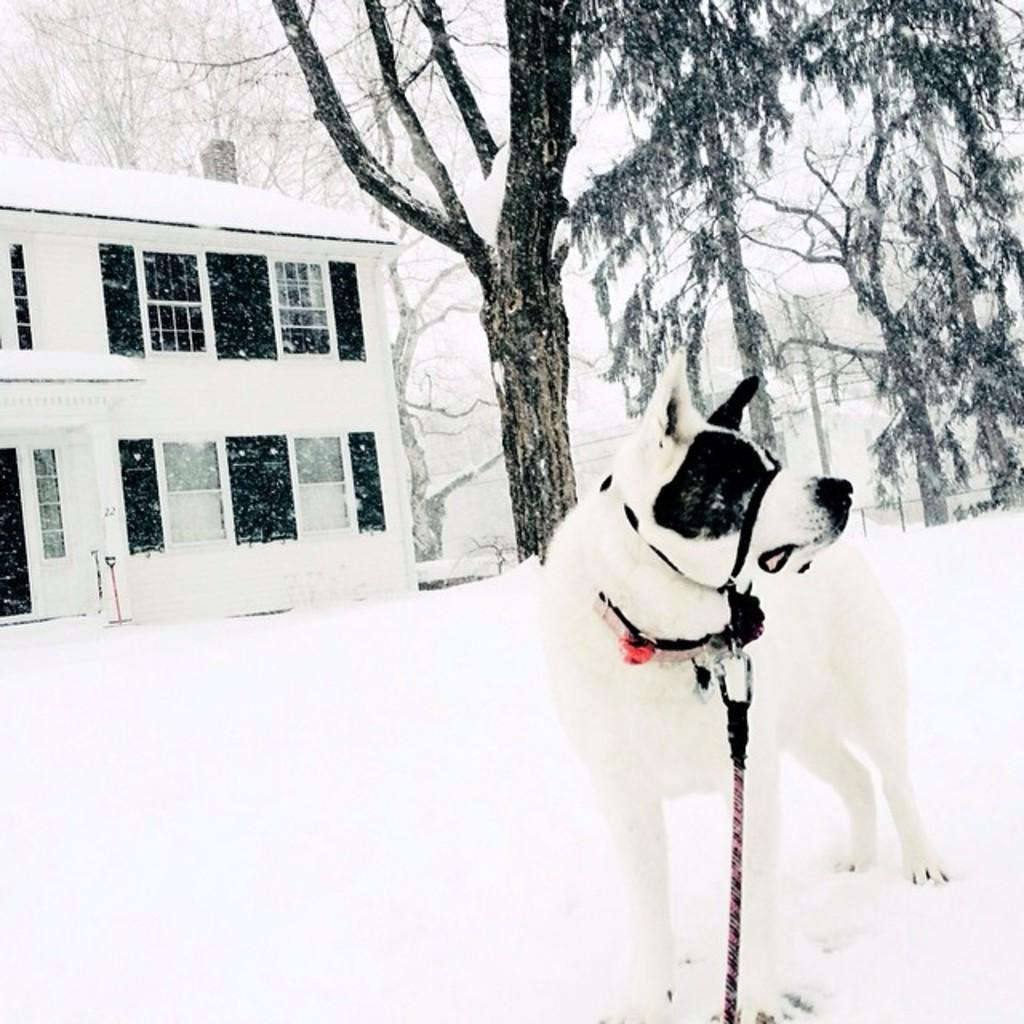What is the setting of the image? The image is taken in a snowy environment. What animal can be seen in the image? There is a dog in the image, tied with a rope. What can be seen in the background of the image? There are trees and buildings in the background of the image. What type of club is the dog holding in the image? There is no club present in the image; the dog is tied with a rope. Can you hear the dog barking in the image? The image is a still photograph, so it does not capture sound. Therefore, we cannot determine if the dog is barking or not. 